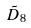<formula> <loc_0><loc_0><loc_500><loc_500>\tilde { D } _ { 8 }</formula> 